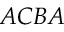Convert formula to latex. <formula><loc_0><loc_0><loc_500><loc_500>A C B A</formula> 